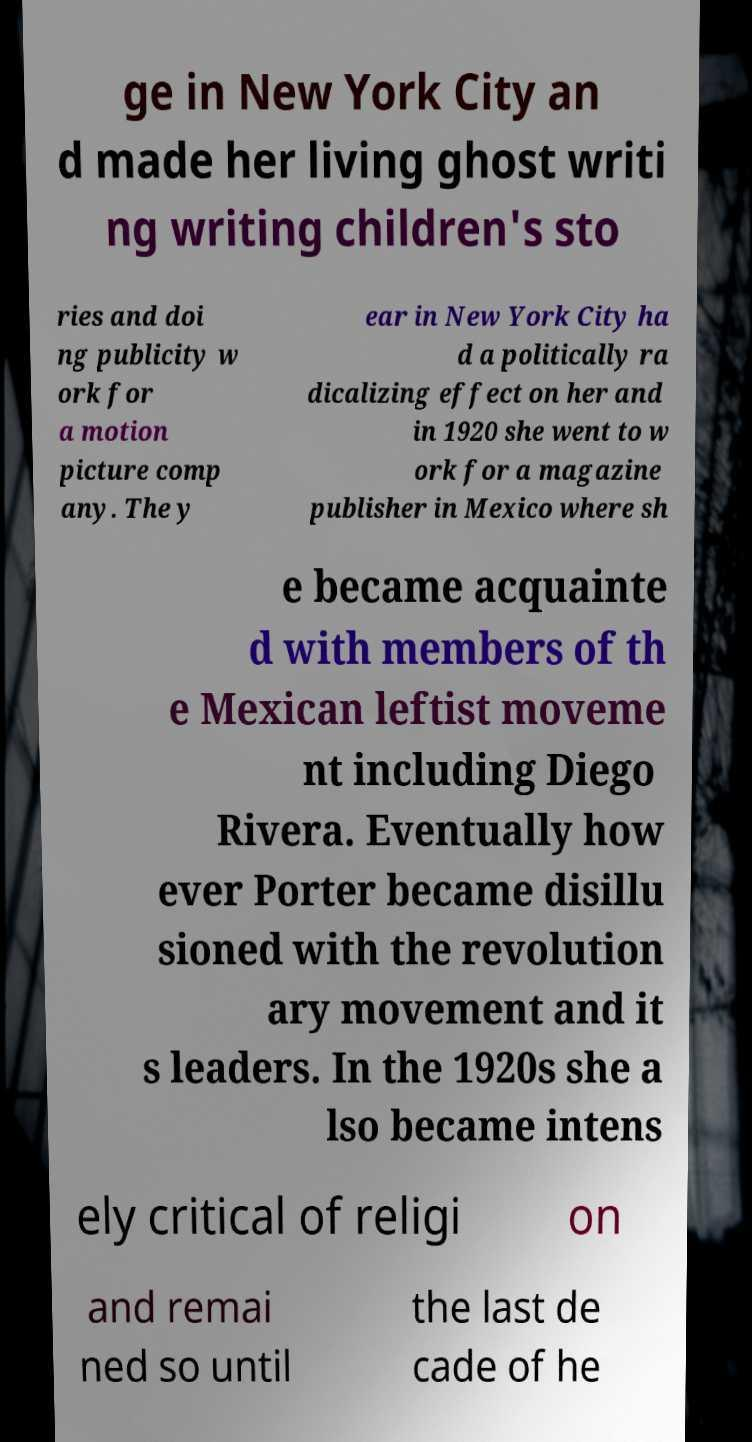Could you extract and type out the text from this image? ge in New York City an d made her living ghost writi ng writing children's sto ries and doi ng publicity w ork for a motion picture comp any. The y ear in New York City ha d a politically ra dicalizing effect on her and in 1920 she went to w ork for a magazine publisher in Mexico where sh e became acquainte d with members of th e Mexican leftist moveme nt including Diego Rivera. Eventually how ever Porter became disillu sioned with the revolution ary movement and it s leaders. In the 1920s she a lso became intens ely critical of religi on and remai ned so until the last de cade of he 